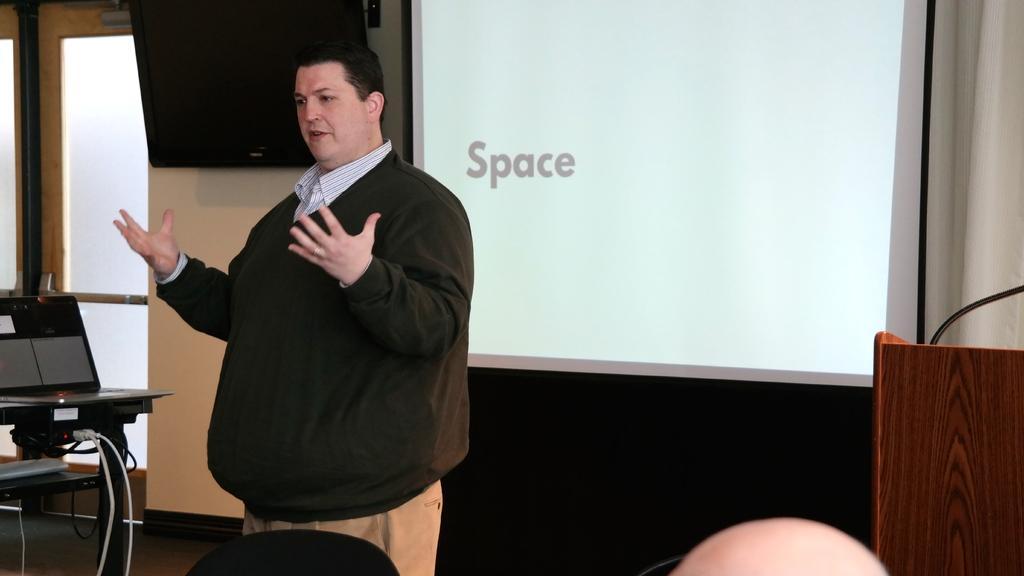Describe this image in one or two sentences. In this image I see a man who is standing and there is a laptop over here and there are few wires. In the background I see the wall, a TV, screen and the podium. 